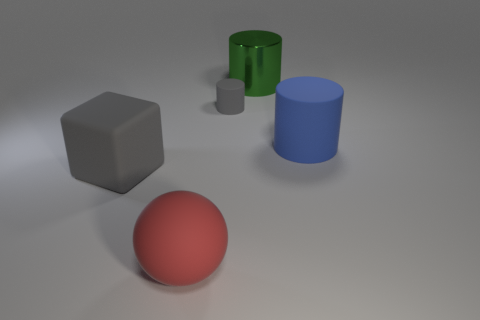There is a gray rubber cylinder; what number of blue matte objects are behind it?
Provide a short and direct response. 0. What is the material of the cylinder in front of the gray matte object that is to the right of the large red object?
Give a very brief answer. Rubber. Is there a cube of the same color as the tiny cylinder?
Your response must be concise. Yes. There is a blue thing that is the same material as the small gray cylinder; what size is it?
Your response must be concise. Large. Is there any other thing of the same color as the small thing?
Ensure brevity in your answer.  Yes. The big matte thing that is right of the red ball is what color?
Your response must be concise. Blue. Are there any objects that are behind the gray rubber thing that is right of the big matte object to the left of the red matte object?
Your response must be concise. Yes. Are there more red things in front of the big blue cylinder than large rubber objects?
Give a very brief answer. No. There is a gray object that is to the left of the small gray cylinder; does it have the same shape as the large metal object?
Ensure brevity in your answer.  No. Is there any other thing that has the same material as the green object?
Offer a terse response. No. 